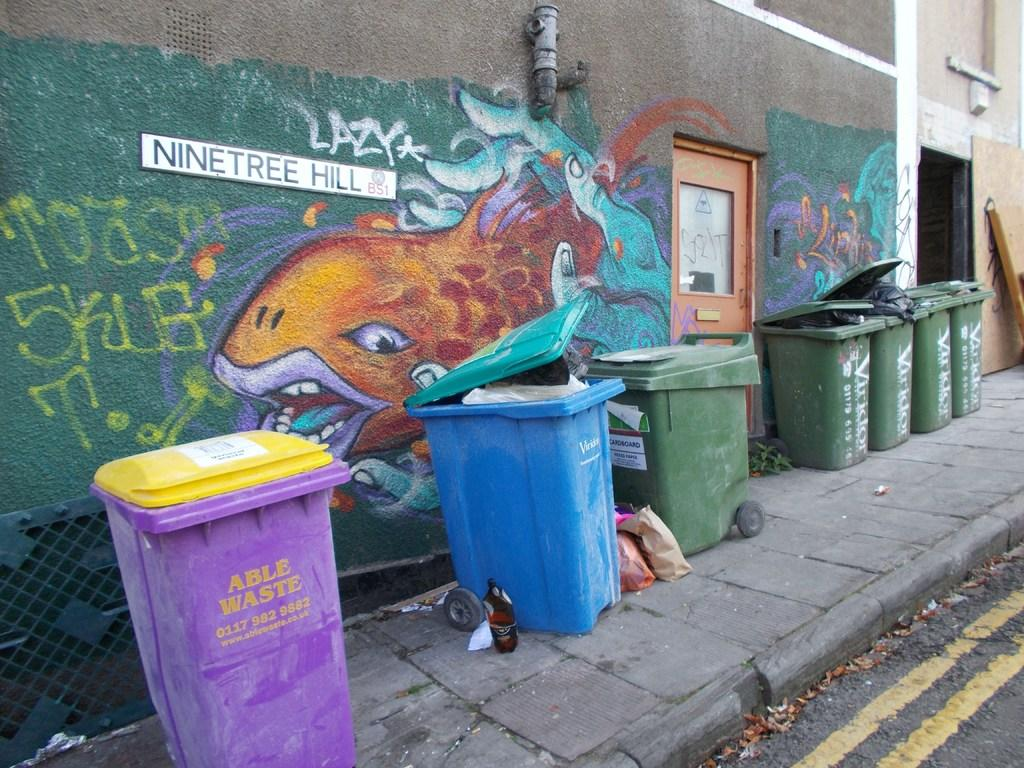<image>
Write a terse but informative summary of the picture. Several garbage cans are outside of a building in Ninetree Hill. 